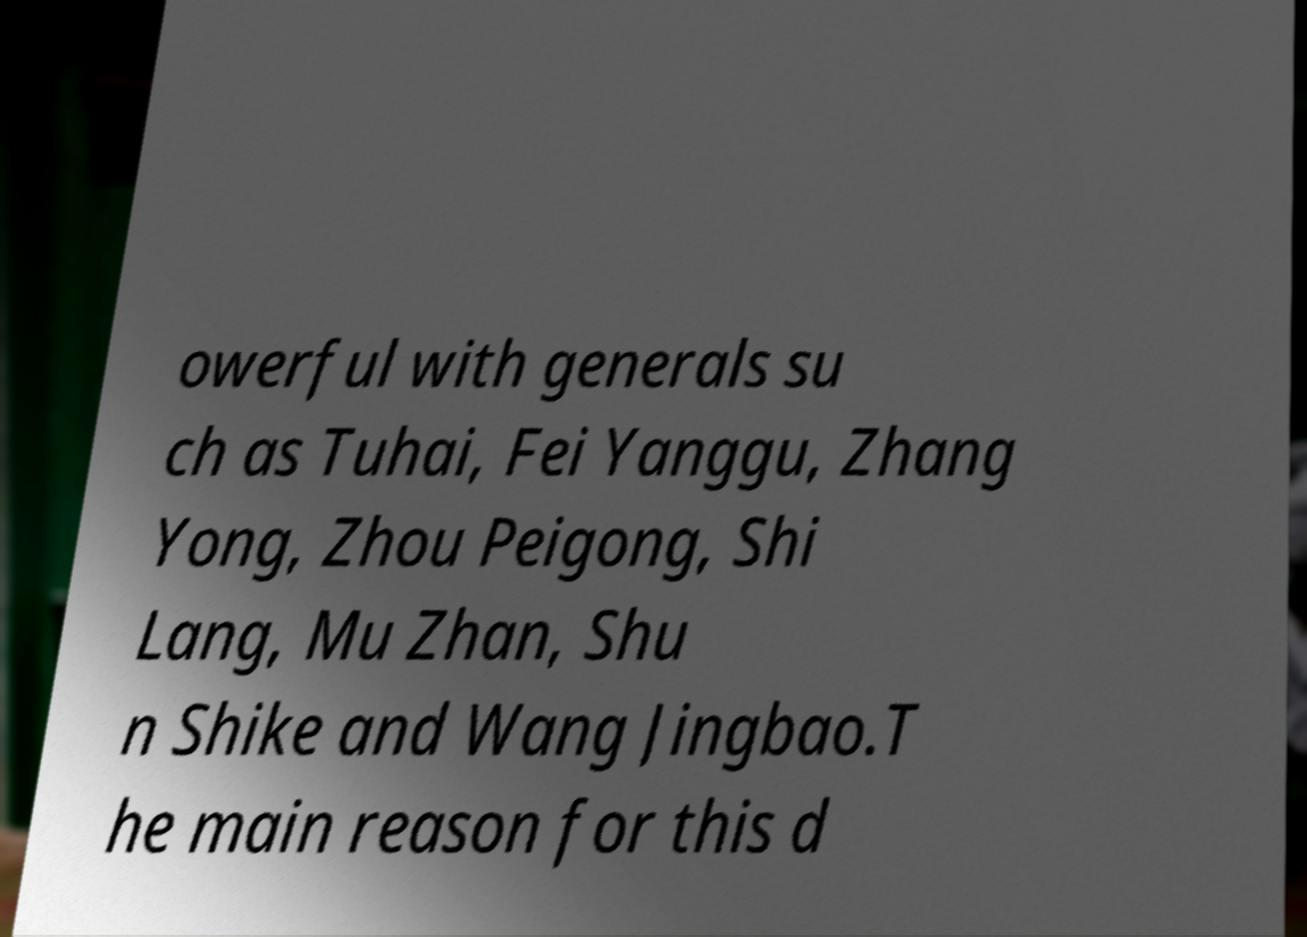Can you read and provide the text displayed in the image?This photo seems to have some interesting text. Can you extract and type it out for me? owerful with generals su ch as Tuhai, Fei Yanggu, Zhang Yong, Zhou Peigong, Shi Lang, Mu Zhan, Shu n Shike and Wang Jingbao.T he main reason for this d 